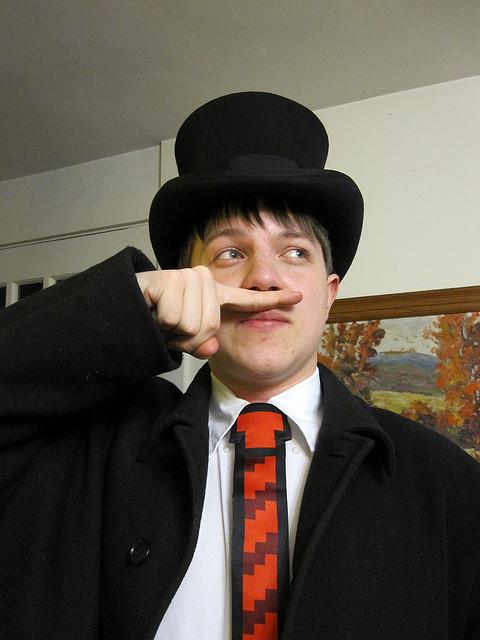What is the man signifying by placing his index finger under his nose?
Be succinct. Mustache. What is the man looking at?
Give a very brief answer. Window. What is his tie supposed to look like?
Keep it brief. Digital. Is this a business outfit?
Keep it brief. No. What kind of hat is this?
Give a very brief answer. Top hat. Is the man wearing a hat?
Concise answer only. Yes. What season is this taken in?
Answer briefly. Fall. Is the man going to sneeze?
Short answer required. No. 